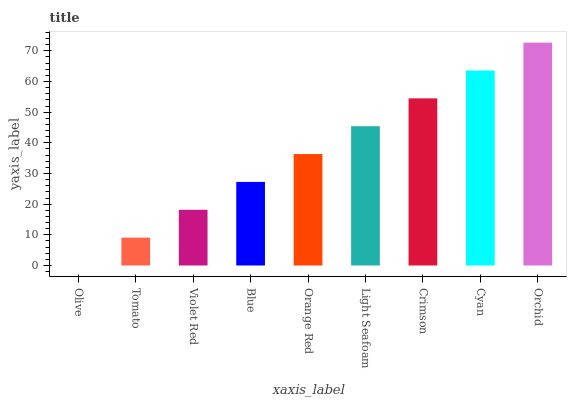Is Olive the minimum?
Answer yes or no. Yes. Is Orchid the maximum?
Answer yes or no. Yes. Is Tomato the minimum?
Answer yes or no. No. Is Tomato the maximum?
Answer yes or no. No. Is Tomato greater than Olive?
Answer yes or no. Yes. Is Olive less than Tomato?
Answer yes or no. Yes. Is Olive greater than Tomato?
Answer yes or no. No. Is Tomato less than Olive?
Answer yes or no. No. Is Orange Red the high median?
Answer yes or no. Yes. Is Orange Red the low median?
Answer yes or no. Yes. Is Olive the high median?
Answer yes or no. No. Is Tomato the low median?
Answer yes or no. No. 